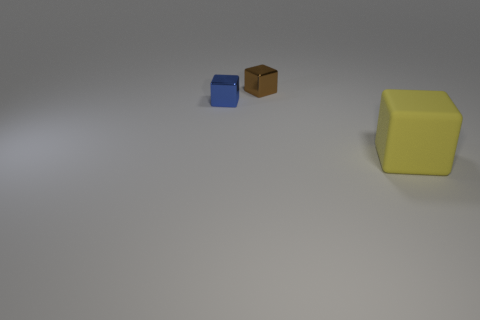Add 1 small cyan rubber spheres. How many objects exist? 4 Add 3 tiny brown shiny objects. How many tiny brown shiny objects are left? 4 Add 1 small green metallic cylinders. How many small green metallic cylinders exist? 1 Subtract 0 purple balls. How many objects are left? 3 Subtract all small blue cubes. Subtract all blue cubes. How many objects are left? 1 